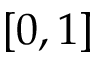<formula> <loc_0><loc_0><loc_500><loc_500>[ 0 , 1 ]</formula> 